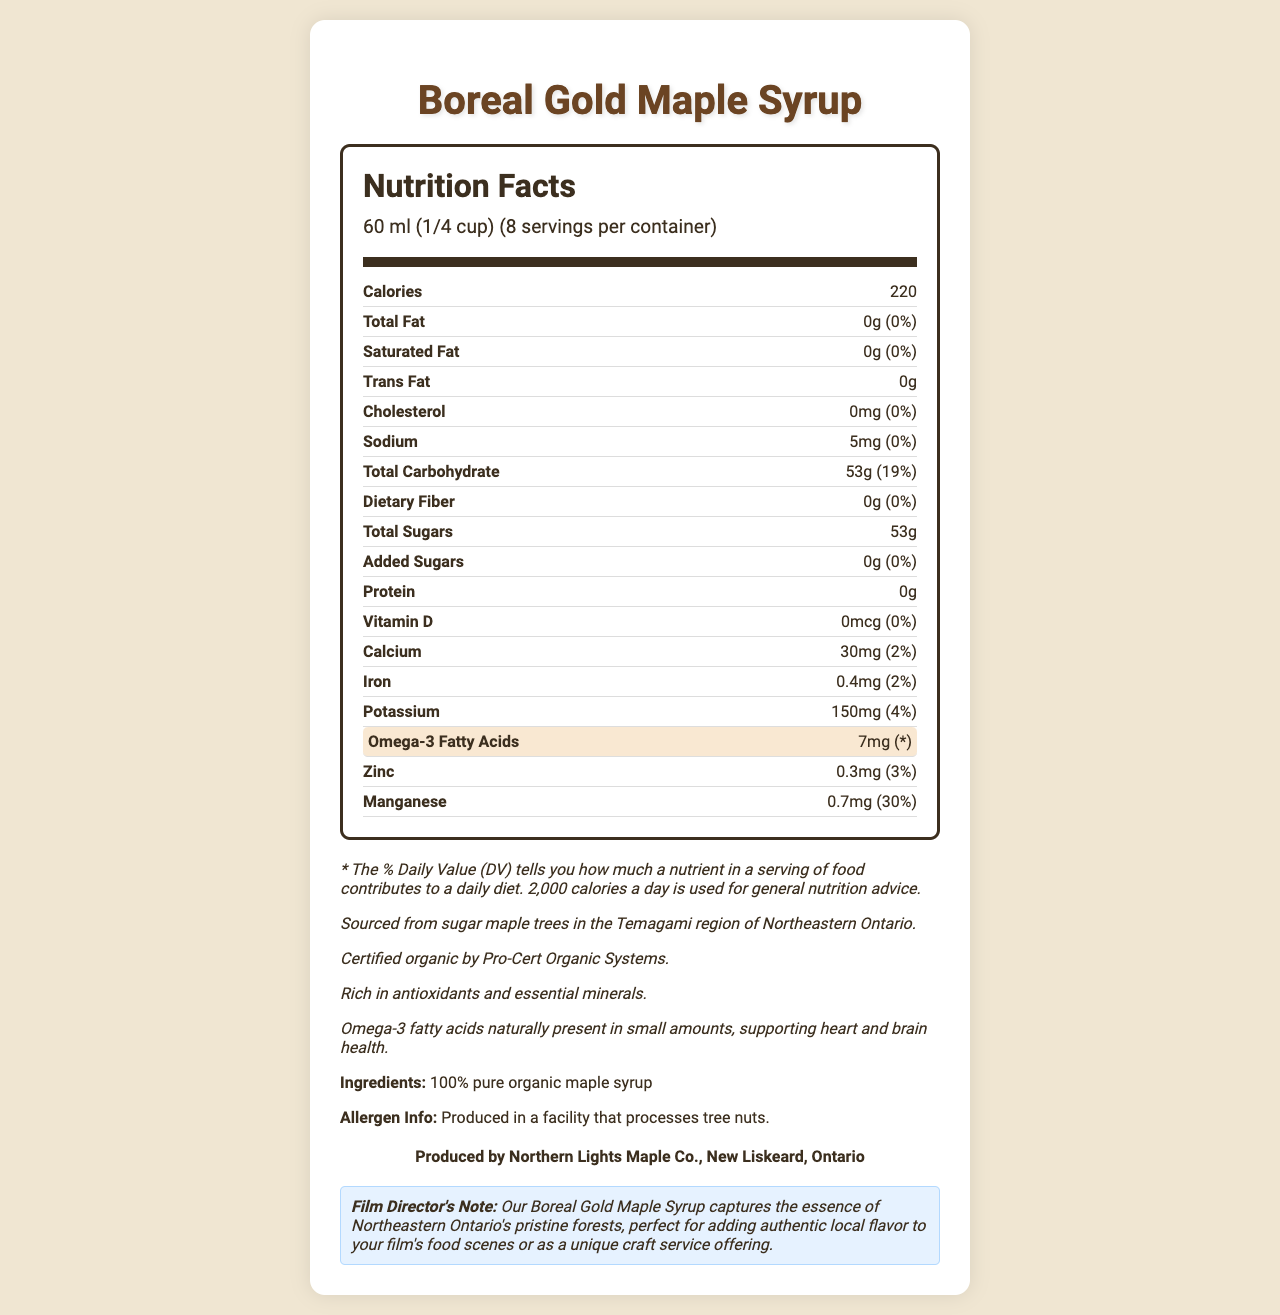What is the serving size of Boreal Gold Maple Syrup? The serving size is clearly stated in the document as "60 ml (1/4 cup)".
Answer: 60 ml (1/4 cup) How many calories are there per serving of the maple syrup? The calories per serving are mentioned as 220.
Answer: 220 What is the amount of Omega-3 fatty acids in each serving? The document specifies that each serving contains 7mg of Omega-3 fatty acids.
Answer: 7mg How much protein is in a serving of this maple syrup? The document indicates that there is 0g of protein per serving.
Answer: 0g What percentage of the daily value of calcium does one serving provide? The document shows that one serving provides 2% of the daily value of calcium.
Answer: 2% How many servings are there per container? The document states that there are 8 servings per container.
Answer: 8 Which nutrient has the highest % daily value in a serving? 
A. Omega-3 Fatty Acids 
B. Manganese 
C. Potassium 
D. Zinc Manganese has the highest % daily value at 30%.
Answer: B What amount of sodium does the syrup contain per serving? 
1. 0mg 
2. 5mg 
3. 150mg 
4. 220mg The syrup contains 5mg of sodium per serving.
Answer: 2 Is the Boreal Gold Maple Syrup produced in a facility that processes tree nuts? The document mentions that it is produced in a facility that processes tree nuts.
Answer: Yes Does the syrup have any added sugars? The document indicates that there are 0g of added sugars.
Answer: No Summarize the nutrition profile and unique features of Boreal Gold Maple Syrup. The summary captures the key nutritional data and unique aspects of the syrup, including its organic certification, mineral content, and Omega-3 fatty acids.
Answer: Boreal Gold Maple Syrup is a certified organic product sourced from sugar maple trees in Northeastern Ontario, containing 220 calories per serving with 0g fat, protein, and dietary fiber. It provides essential minerals such as calcium, iron, potassium, zinc, and manganese, and includes small amounts of Omega-3 fatty acids for heart and brain health. What is the concentration of manganese in Boreal Gold Maple Syrup? The document gives the amount and % daily value but does not specify the concentration in terms of mg/ml or other units.
Answer: Not enough information 